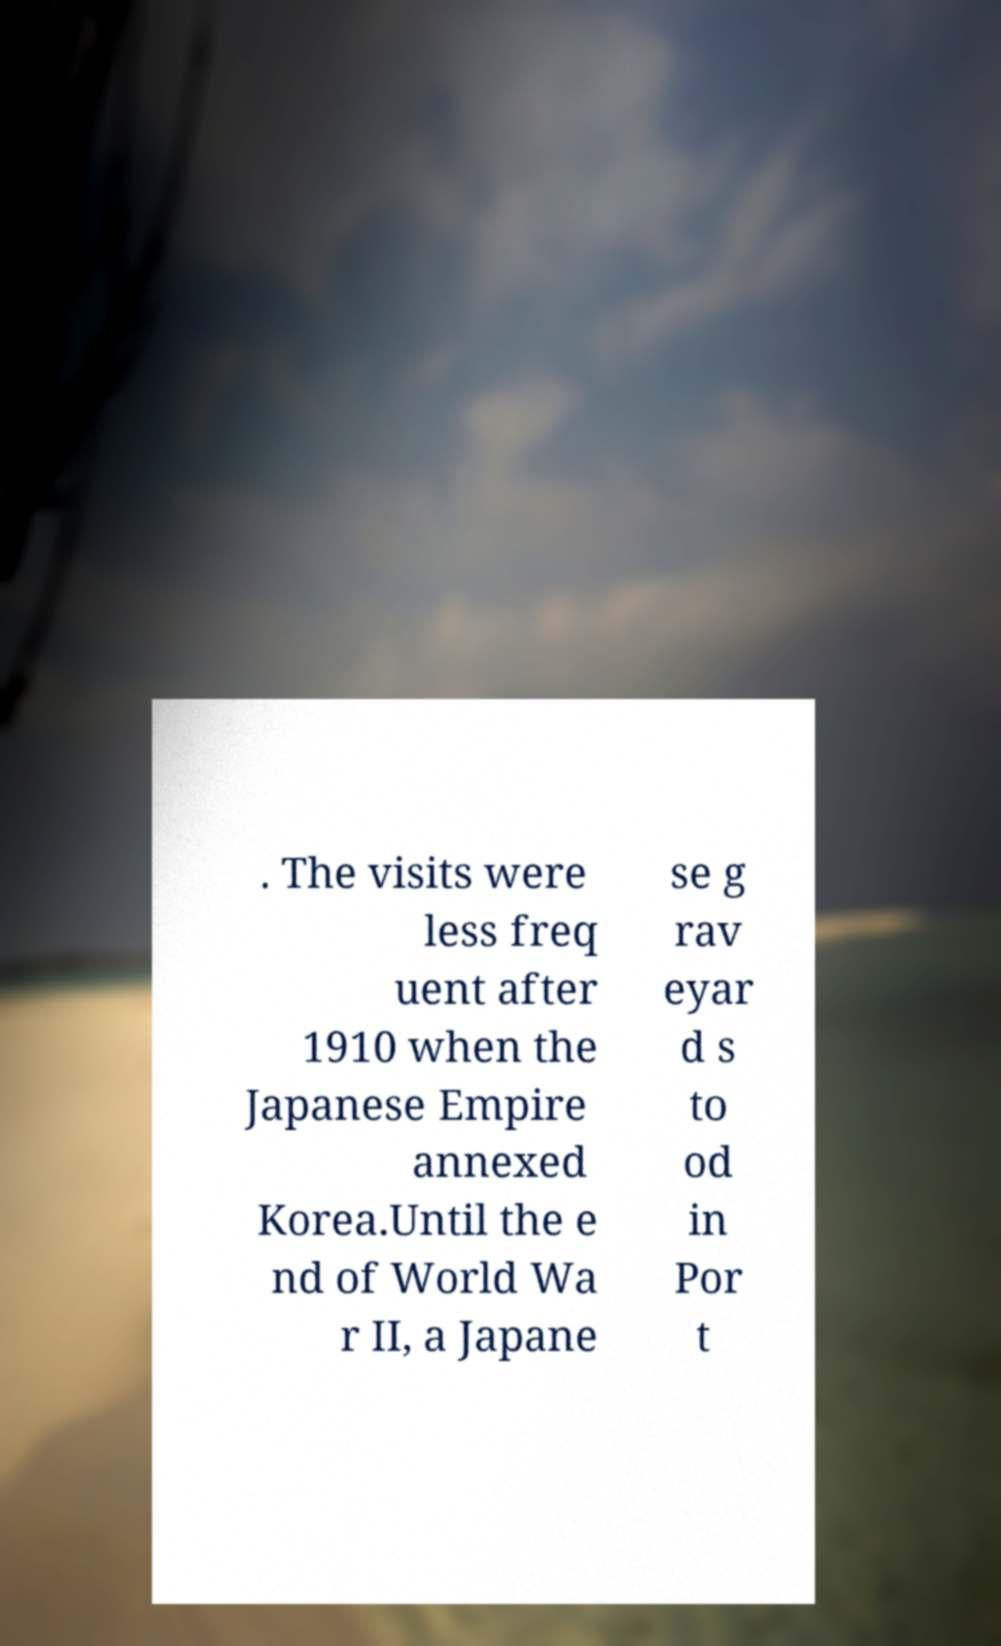Could you extract and type out the text from this image? . The visits were less freq uent after 1910 when the Japanese Empire annexed Korea.Until the e nd of World Wa r II, a Japane se g rav eyar d s to od in Por t 